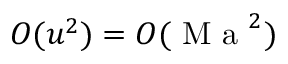<formula> <loc_0><loc_0><loc_500><loc_500>O ( u ^ { 2 } ) = O ( M a ^ { 2 } )</formula> 